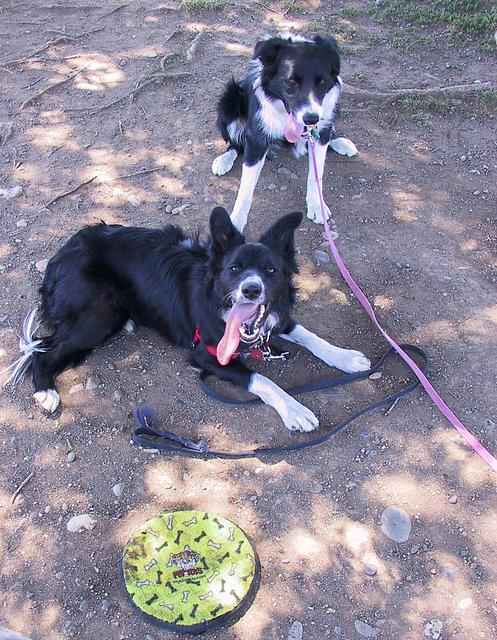What color is the lead to the dog standing to the rear side of the black dog?

Choices:
A) green
B) purple
C) pink
D) white pink 